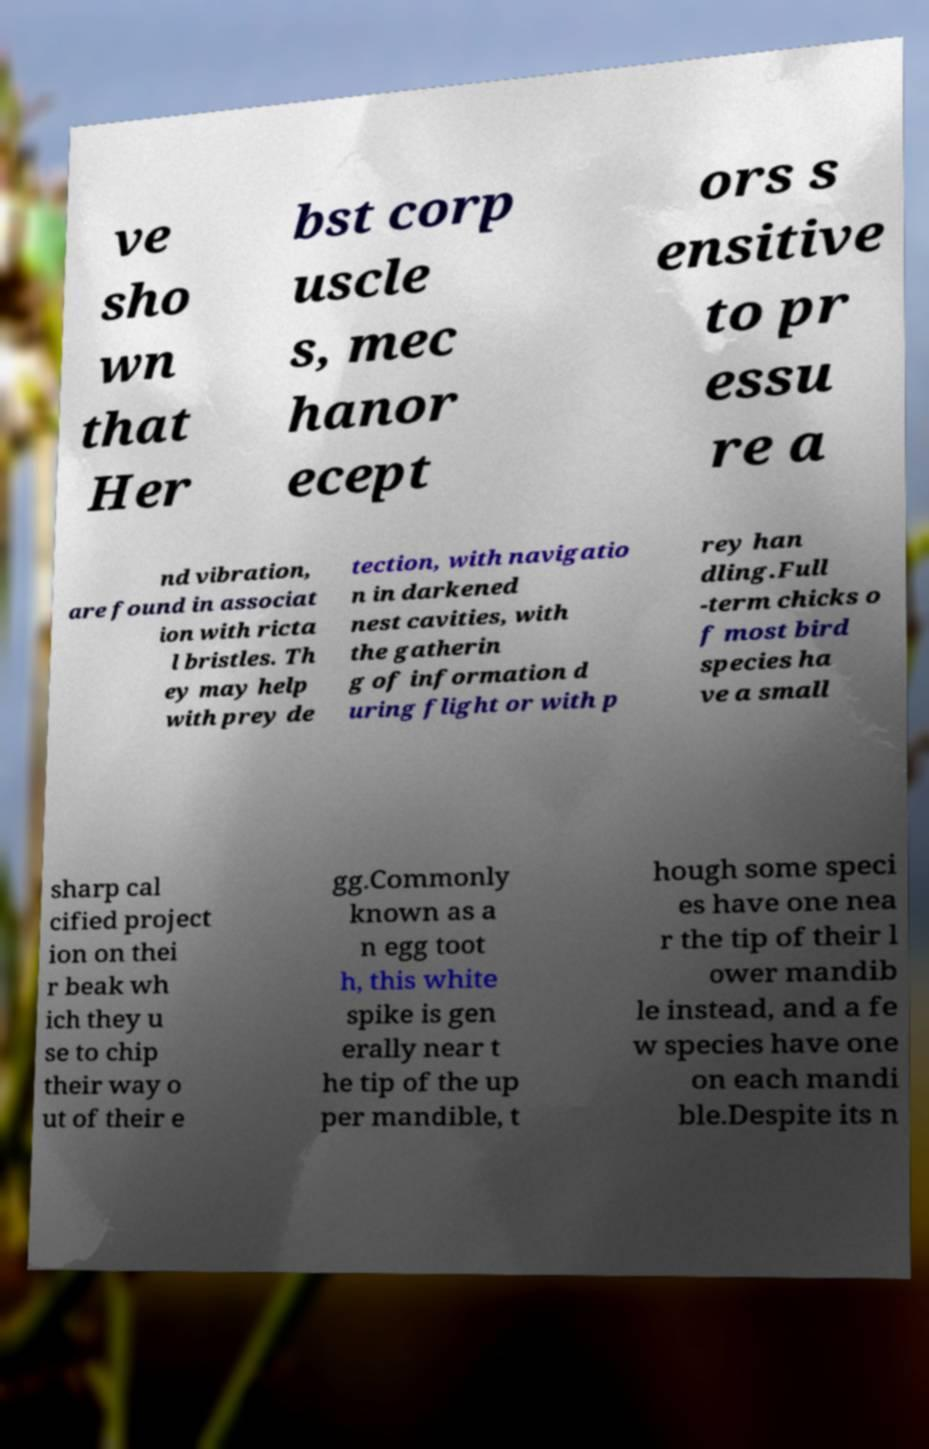What messages or text are displayed in this image? I need them in a readable, typed format. ve sho wn that Her bst corp uscle s, mec hanor ecept ors s ensitive to pr essu re a nd vibration, are found in associat ion with ricta l bristles. Th ey may help with prey de tection, with navigatio n in darkened nest cavities, with the gatherin g of information d uring flight or with p rey han dling.Full -term chicks o f most bird species ha ve a small sharp cal cified project ion on thei r beak wh ich they u se to chip their way o ut of their e gg.Commonly known as a n egg toot h, this white spike is gen erally near t he tip of the up per mandible, t hough some speci es have one nea r the tip of their l ower mandib le instead, and a fe w species have one on each mandi ble.Despite its n 